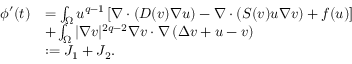Convert formula to latex. <formula><loc_0><loc_0><loc_500><loc_500>\begin{array} { r l } { \phi ^ { \prime } ( t ) } & { = \int _ { \Omega } u ^ { q - 1 } \left [ \nabla \cdot ( D ( v ) \nabla u ) - \nabla \cdot ( S ( v ) u \nabla v ) + f ( u ) \right ] } \\ & { + \int _ { \Omega } | \nabla v | ^ { 2 q - 2 } \nabla v \cdot \nabla \left ( \Delta v + u - v \right ) } \\ & { \colon = J _ { 1 } + J _ { 2 } . } \end{array}</formula> 